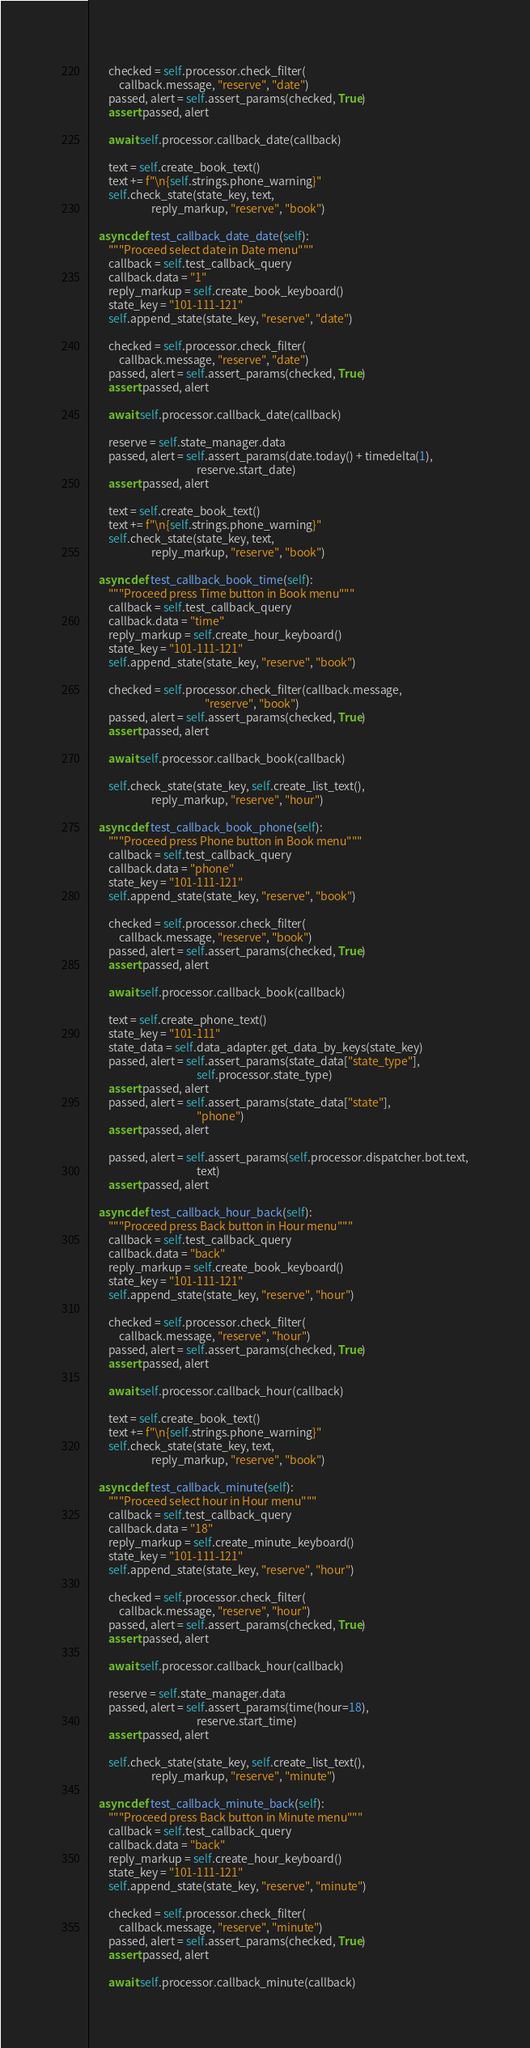<code> <loc_0><loc_0><loc_500><loc_500><_Python_>
        checked = self.processor.check_filter(
            callback.message, "reserve", "date")
        passed, alert = self.assert_params(checked, True)
        assert passed, alert

        await self.processor.callback_date(callback)

        text = self.create_book_text()
        text += f"\n{self.strings.phone_warning}"
        self.check_state(state_key, text,
                         reply_markup, "reserve", "book")

    async def test_callback_date_date(self):
        """Proceed select date in Date menu"""
        callback = self.test_callback_query
        callback.data = "1"
        reply_markup = self.create_book_keyboard()
        state_key = "101-111-121"
        self.append_state(state_key, "reserve", "date")

        checked = self.processor.check_filter(
            callback.message, "reserve", "date")
        passed, alert = self.assert_params(checked, True)
        assert passed, alert

        await self.processor.callback_date(callback)

        reserve = self.state_manager.data
        passed, alert = self.assert_params(date.today() + timedelta(1),
                                           reserve.start_date)
        assert passed, alert

        text = self.create_book_text()
        text += f"\n{self.strings.phone_warning}"
        self.check_state(state_key, text,
                         reply_markup, "reserve", "book")

    async def test_callback_book_time(self):
        """Proceed press Time button in Book menu"""
        callback = self.test_callback_query
        callback.data = "time"
        reply_markup = self.create_hour_keyboard()
        state_key = "101-111-121"
        self.append_state(state_key, "reserve", "book")

        checked = self.processor.check_filter(callback.message,
                                              "reserve", "book")
        passed, alert = self.assert_params(checked, True)
        assert passed, alert

        await self.processor.callback_book(callback)

        self.check_state(state_key, self.create_list_text(),
                         reply_markup, "reserve", "hour")

    async def test_callback_book_phone(self):
        """Proceed press Phone button in Book menu"""
        callback = self.test_callback_query
        callback.data = "phone"
        state_key = "101-111-121"
        self.append_state(state_key, "reserve", "book")

        checked = self.processor.check_filter(
            callback.message, "reserve", "book")
        passed, alert = self.assert_params(checked, True)
        assert passed, alert

        await self.processor.callback_book(callback)

        text = self.create_phone_text()
        state_key = "101-111"
        state_data = self.data_adapter.get_data_by_keys(state_key)
        passed, alert = self.assert_params(state_data["state_type"],
                                           self.processor.state_type)
        assert passed, alert
        passed, alert = self.assert_params(state_data["state"],
                                           "phone")
        assert passed, alert

        passed, alert = self.assert_params(self.processor.dispatcher.bot.text,
                                           text)
        assert passed, alert

    async def test_callback_hour_back(self):
        """Proceed press Back button in Hour menu"""
        callback = self.test_callback_query
        callback.data = "back"
        reply_markup = self.create_book_keyboard()
        state_key = "101-111-121"
        self.append_state(state_key, "reserve", "hour")

        checked = self.processor.check_filter(
            callback.message, "reserve", "hour")
        passed, alert = self.assert_params(checked, True)
        assert passed, alert

        await self.processor.callback_hour(callback)

        text = self.create_book_text()
        text += f"\n{self.strings.phone_warning}"
        self.check_state(state_key, text,
                         reply_markup, "reserve", "book")

    async def test_callback_minute(self):
        """Proceed select hour in Hour menu"""
        callback = self.test_callback_query
        callback.data = "18"
        reply_markup = self.create_minute_keyboard()
        state_key = "101-111-121"
        self.append_state(state_key, "reserve", "hour")

        checked = self.processor.check_filter(
            callback.message, "reserve", "hour")
        passed, alert = self.assert_params(checked, True)
        assert passed, alert

        await self.processor.callback_hour(callback)

        reserve = self.state_manager.data
        passed, alert = self.assert_params(time(hour=18),
                                           reserve.start_time)
        assert passed, alert

        self.check_state(state_key, self.create_list_text(),
                         reply_markup, "reserve", "minute")

    async def test_callback_minute_back(self):
        """Proceed press Back button in Minute menu"""
        callback = self.test_callback_query
        callback.data = "back"
        reply_markup = self.create_hour_keyboard()
        state_key = "101-111-121"
        self.append_state(state_key, "reserve", "minute")

        checked = self.processor.check_filter(
            callback.message, "reserve", "minute")
        passed, alert = self.assert_params(checked, True)
        assert passed, alert

        await self.processor.callback_minute(callback)
</code> 